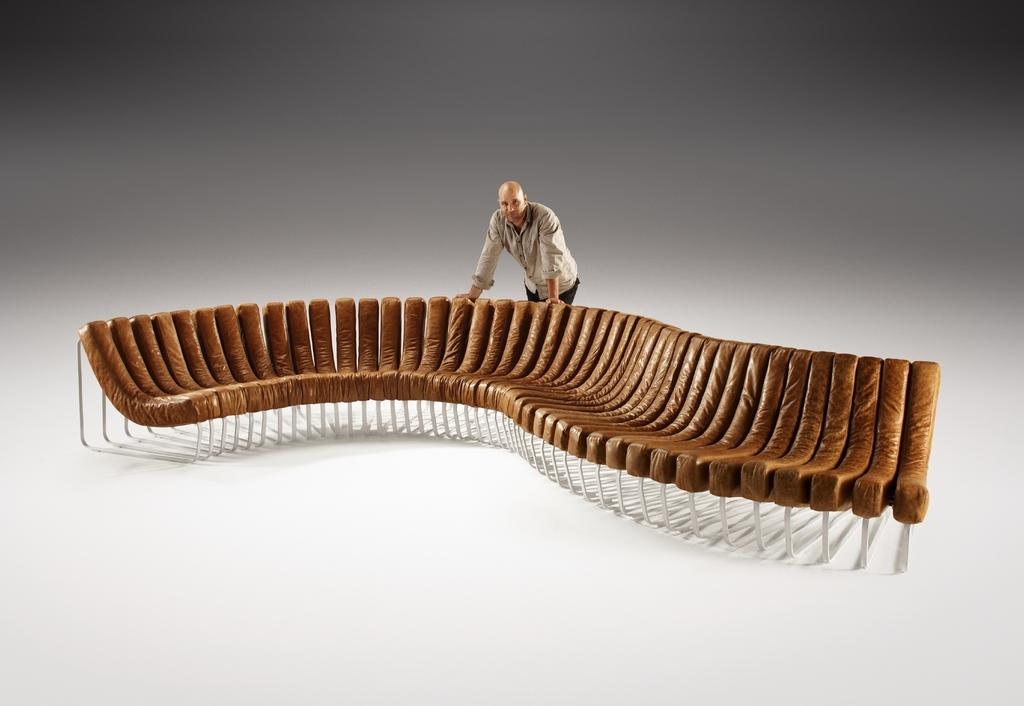What piece of furniture is located in the center of the image? There is a sofa in the center of the image. Can you describe the person in the image? There is a man in the image. What type of vegetable is the man holding in the image? There is no vegetable present in the image; the man is not holding anything. 